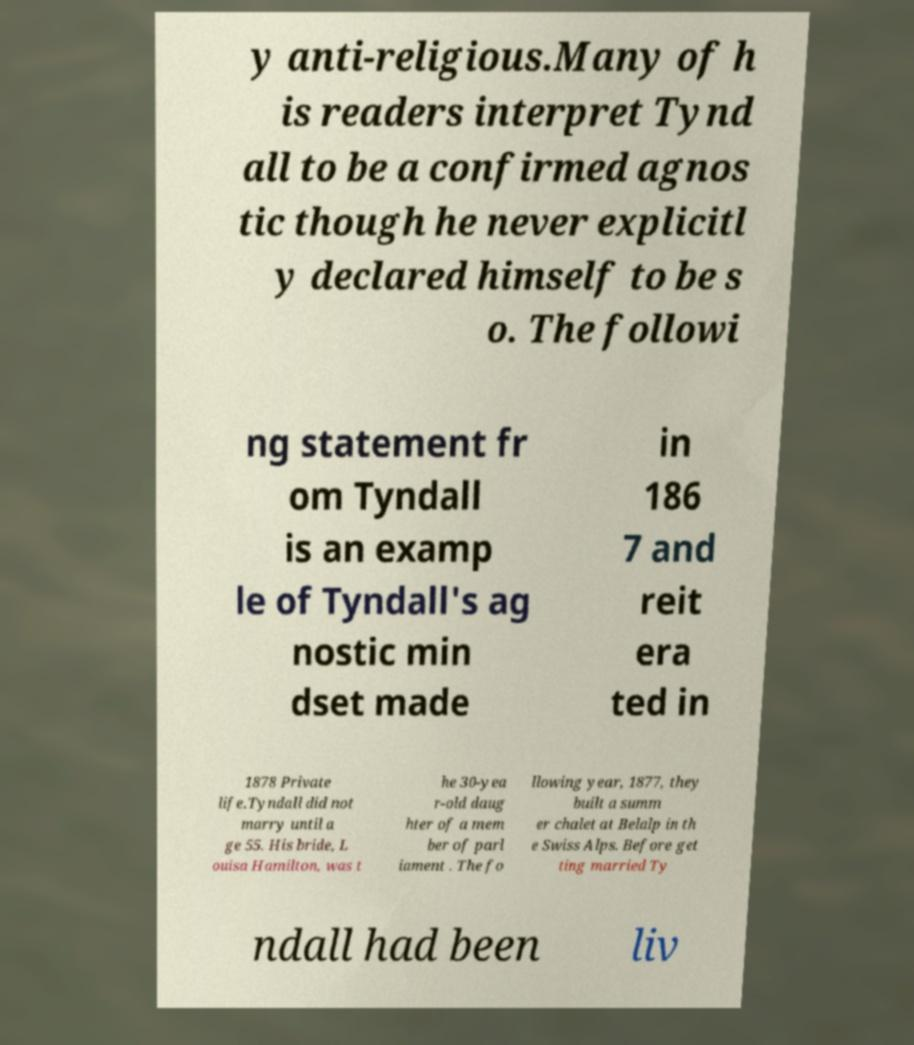Could you assist in decoding the text presented in this image and type it out clearly? y anti-religious.Many of h is readers interpret Tynd all to be a confirmed agnos tic though he never explicitl y declared himself to be s o. The followi ng statement fr om Tyndall is an examp le of Tyndall's ag nostic min dset made in 186 7 and reit era ted in 1878 Private life.Tyndall did not marry until a ge 55. His bride, L ouisa Hamilton, was t he 30-yea r-old daug hter of a mem ber of parl iament . The fo llowing year, 1877, they built a summ er chalet at Belalp in th e Swiss Alps. Before get ting married Ty ndall had been liv 